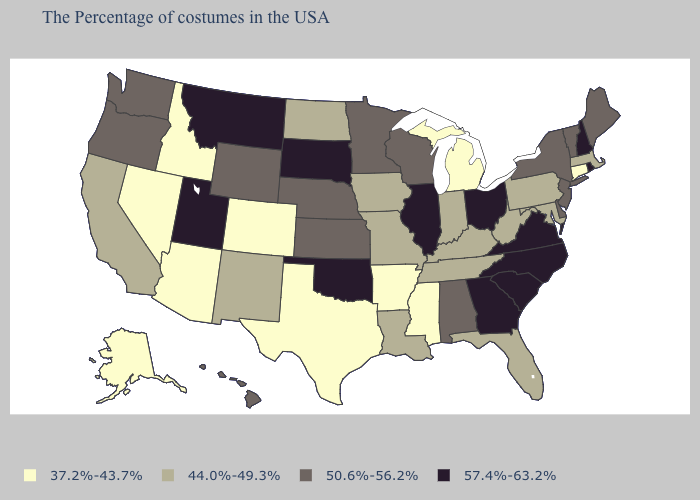Does North Carolina have the lowest value in the South?
Short answer required. No. Name the states that have a value in the range 37.2%-43.7%?
Give a very brief answer. Connecticut, Michigan, Mississippi, Arkansas, Texas, Colorado, Arizona, Idaho, Nevada, Alaska. What is the value of Michigan?
Concise answer only. 37.2%-43.7%. Name the states that have a value in the range 37.2%-43.7%?
Short answer required. Connecticut, Michigan, Mississippi, Arkansas, Texas, Colorado, Arizona, Idaho, Nevada, Alaska. What is the value of Alabama?
Short answer required. 50.6%-56.2%. Name the states that have a value in the range 37.2%-43.7%?
Be succinct. Connecticut, Michigan, Mississippi, Arkansas, Texas, Colorado, Arizona, Idaho, Nevada, Alaska. How many symbols are there in the legend?
Keep it brief. 4. Name the states that have a value in the range 57.4%-63.2%?
Write a very short answer. Rhode Island, New Hampshire, Virginia, North Carolina, South Carolina, Ohio, Georgia, Illinois, Oklahoma, South Dakota, Utah, Montana. Does Ohio have the highest value in the MidWest?
Write a very short answer. Yes. Does the first symbol in the legend represent the smallest category?
Quick response, please. Yes. What is the value of North Dakota?
Quick response, please. 44.0%-49.3%. What is the value of Mississippi?
Give a very brief answer. 37.2%-43.7%. Which states have the highest value in the USA?
Answer briefly. Rhode Island, New Hampshire, Virginia, North Carolina, South Carolina, Ohio, Georgia, Illinois, Oklahoma, South Dakota, Utah, Montana. Which states have the highest value in the USA?
Be succinct. Rhode Island, New Hampshire, Virginia, North Carolina, South Carolina, Ohio, Georgia, Illinois, Oklahoma, South Dakota, Utah, Montana. 